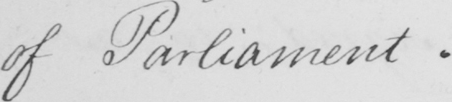Please provide the text content of this handwritten line. of Parliament . 